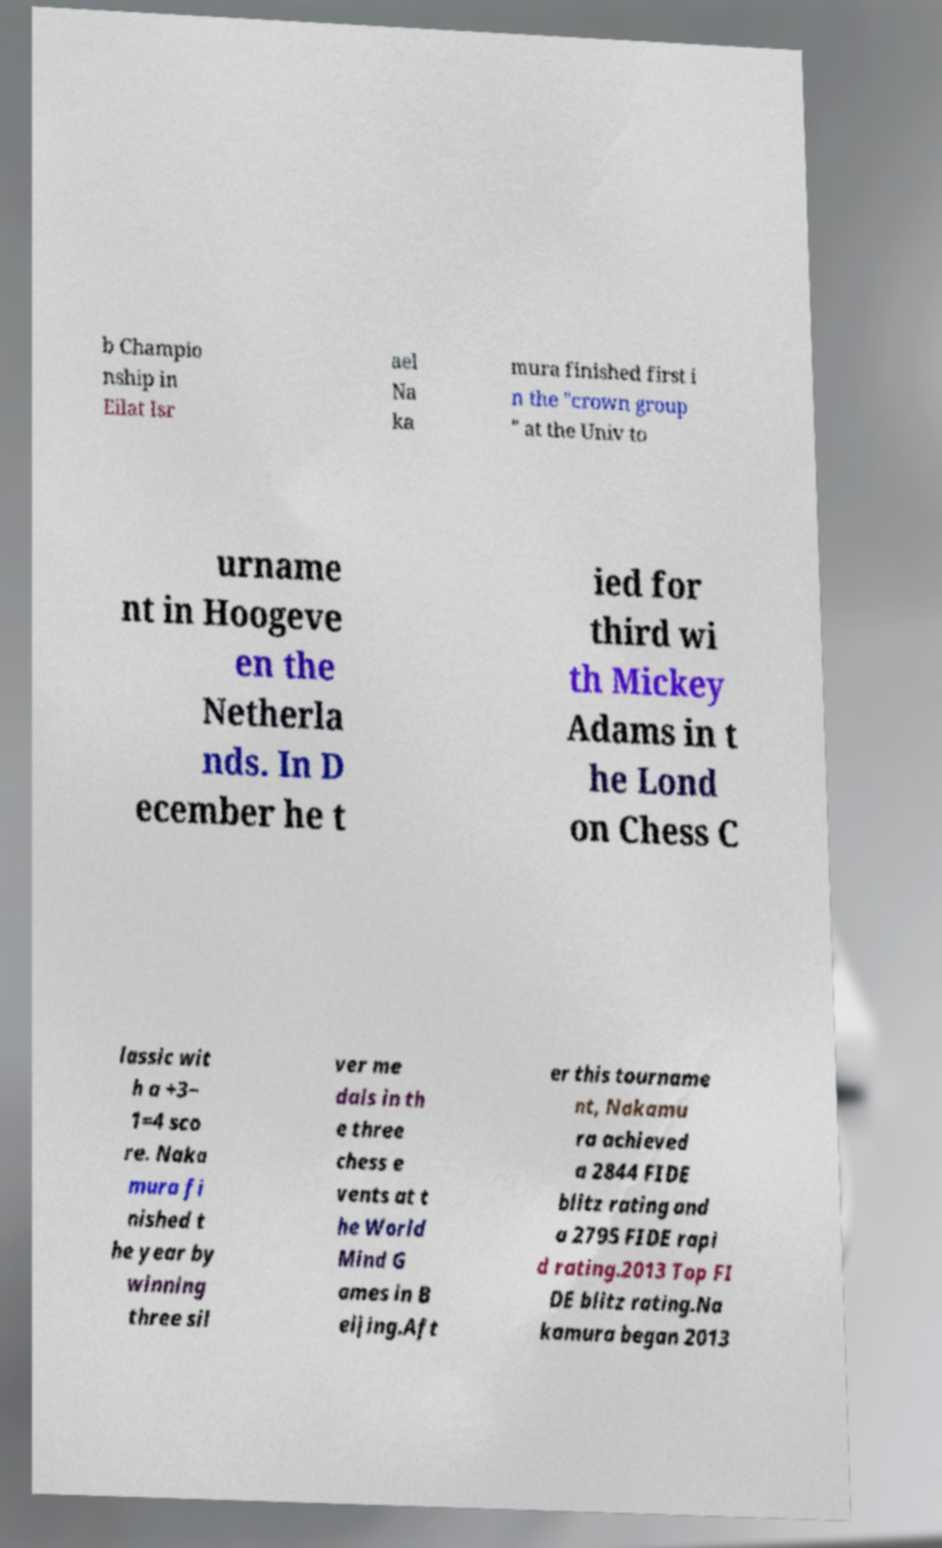Please identify and transcribe the text found in this image. b Champio nship in Eilat Isr ael Na ka mura finished first i n the "crown group " at the Univ to urname nt in Hoogeve en the Netherla nds. In D ecember he t ied for third wi th Mickey Adams in t he Lond on Chess C lassic wit h a +3− 1=4 sco re. Naka mura fi nished t he year by winning three sil ver me dals in th e three chess e vents at t he World Mind G ames in B eijing.Aft er this tourname nt, Nakamu ra achieved a 2844 FIDE blitz rating and a 2795 FIDE rapi d rating.2013 Top FI DE blitz rating.Na kamura began 2013 